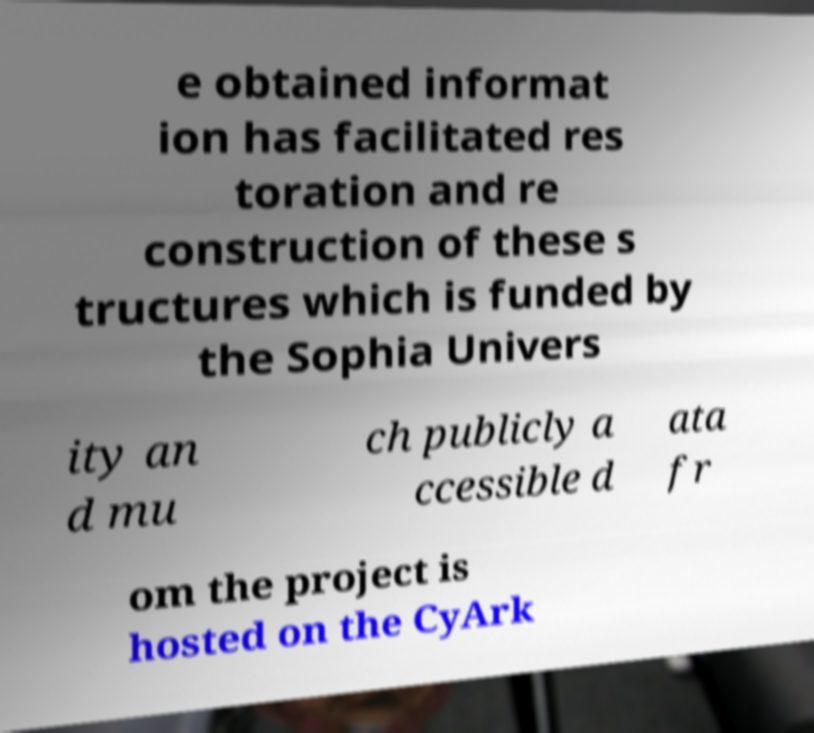Can you read and provide the text displayed in the image?This photo seems to have some interesting text. Can you extract and type it out for me? e obtained informat ion has facilitated res toration and re construction of these s tructures which is funded by the Sophia Univers ity an d mu ch publicly a ccessible d ata fr om the project is hosted on the CyArk 